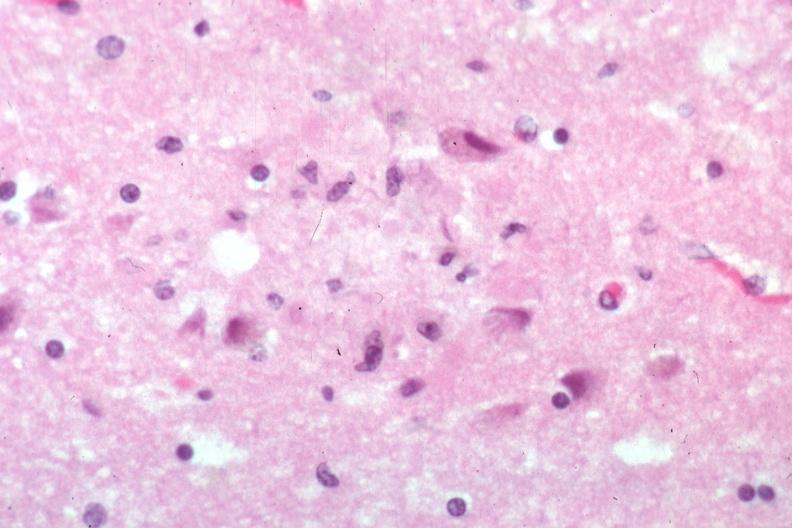s brain present?
Answer the question using a single word or phrase. Yes 